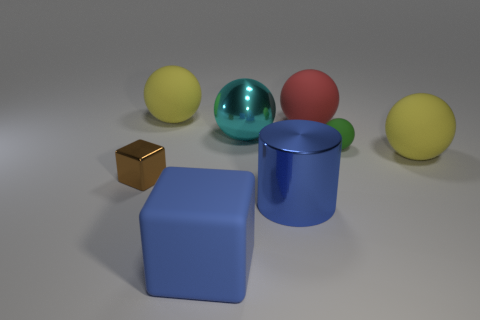Subtract all yellow spheres. How many were subtracted if there are1yellow spheres left? 1 Subtract all green matte balls. How many balls are left? 4 Subtract all green balls. How many balls are left? 4 Subtract all gray spheres. Subtract all blue blocks. How many spheres are left? 5 Add 1 yellow rubber balls. How many objects exist? 9 Subtract all cylinders. How many objects are left? 7 Add 7 tiny brown metal objects. How many tiny brown metal objects exist? 8 Subtract 0 blue spheres. How many objects are left? 8 Subtract all cyan balls. Subtract all blue rubber things. How many objects are left? 6 Add 7 blue metallic objects. How many blue metallic objects are left? 8 